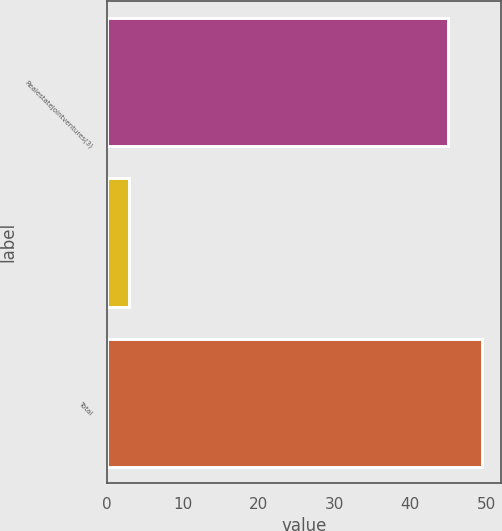Convert chart. <chart><loc_0><loc_0><loc_500><loc_500><bar_chart><fcel>Realestatejointventures(3)<fcel>Unnamed: 1<fcel>Total<nl><fcel>45<fcel>3<fcel>49.5<nl></chart> 